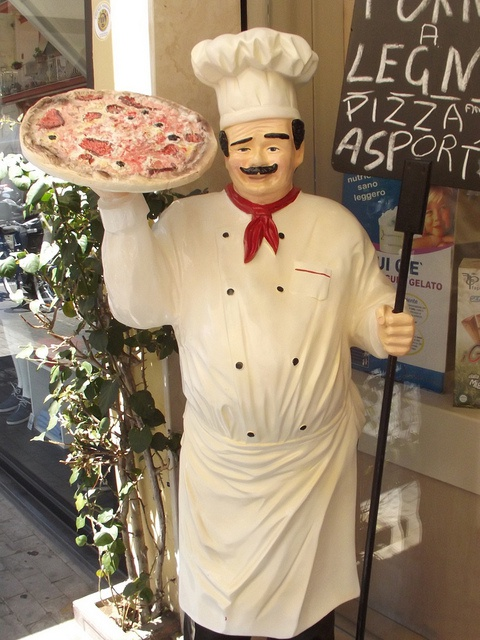Describe the objects in this image and their specific colors. I can see people in darkgreen, tan, and beige tones, potted plant in darkgreen, black, ivory, and gray tones, pizza in darkgreen, tan, and salmon tones, and people in darkgreen, maroon, brown, and black tones in this image. 